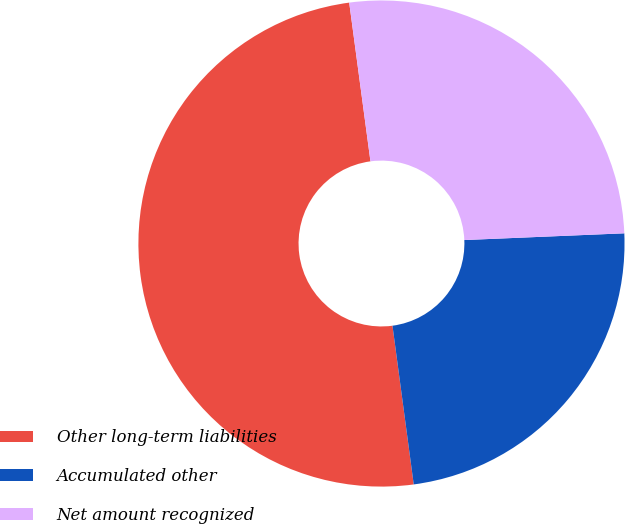<chart> <loc_0><loc_0><loc_500><loc_500><pie_chart><fcel>Other long-term liabilities<fcel>Accumulated other<fcel>Net amount recognized<nl><fcel>50.0%<fcel>23.55%<fcel>26.45%<nl></chart> 